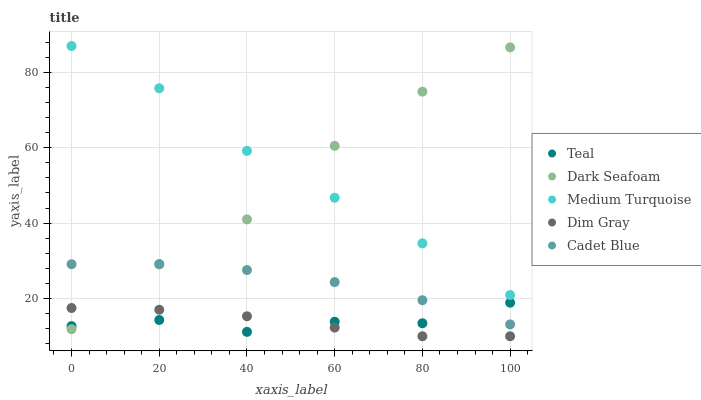Does Dim Gray have the minimum area under the curve?
Answer yes or no. Yes. Does Medium Turquoise have the maximum area under the curve?
Answer yes or no. Yes. Does Dark Seafoam have the minimum area under the curve?
Answer yes or no. No. Does Dark Seafoam have the maximum area under the curve?
Answer yes or no. No. Is Dim Gray the smoothest?
Answer yes or no. Yes. Is Dark Seafoam the roughest?
Answer yes or no. Yes. Is Dark Seafoam the smoothest?
Answer yes or no. No. Is Dim Gray the roughest?
Answer yes or no. No. Does Dim Gray have the lowest value?
Answer yes or no. Yes. Does Dark Seafoam have the lowest value?
Answer yes or no. No. Does Medium Turquoise have the highest value?
Answer yes or no. Yes. Does Dark Seafoam have the highest value?
Answer yes or no. No. Is Dim Gray less than Cadet Blue?
Answer yes or no. Yes. Is Cadet Blue greater than Dim Gray?
Answer yes or no. Yes. Does Teal intersect Cadet Blue?
Answer yes or no. Yes. Is Teal less than Cadet Blue?
Answer yes or no. No. Is Teal greater than Cadet Blue?
Answer yes or no. No. Does Dim Gray intersect Cadet Blue?
Answer yes or no. No. 